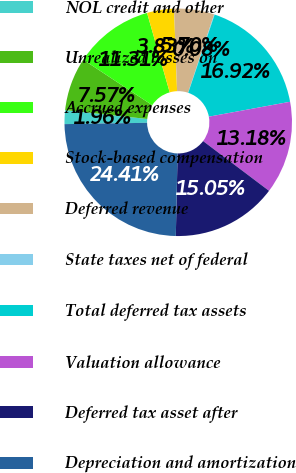Convert chart to OTSL. <chart><loc_0><loc_0><loc_500><loc_500><pie_chart><fcel>NOL credit and other<fcel>Unrealized losses on<fcel>Accrued expenses<fcel>Stock-based compensation<fcel>Deferred revenue<fcel>State taxes net of federal<fcel>Total deferred tax assets<fcel>Valuation allowance<fcel>Deferred tax asset after<fcel>Depreciation and amortization<nl><fcel>1.96%<fcel>7.57%<fcel>11.31%<fcel>3.83%<fcel>5.7%<fcel>0.08%<fcel>16.92%<fcel>13.18%<fcel>15.05%<fcel>24.41%<nl></chart> 